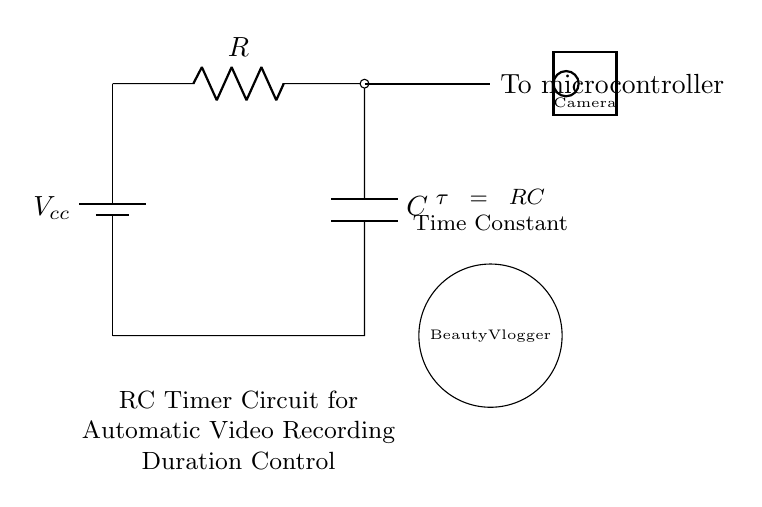What is the component labeled R? The component labeled R represents a resistor, which is used to limit current in the circuit.
Answer: Resistor What is the component labeled C? The component labeled C represents a capacitor, which stores electrical energy temporarily.
Answer: Capacitor What connects to the microcontroller? The output from the RC circuit, which is the point where the resistor and capacitor meet before going to the microcontroller, connects to it.
Answer: Resistor-Capacitor output What is the purpose of this circuit? This circuit is designed to control the duration of automatic video recording by utilizing the time constant from the resistor and capacitor.
Answer: Automatic video recording duration control What is the time constant of this circuit? The time constant (tau) of the circuit is calculated by the product of the resistor value and capacitor value, represented as tau equals RC.
Answer: RC How does the time constant impact the recording duration? The time constant determines how quickly the capacitor charges and discharges, directly affecting the time before the microcontroller receives a signal to stop recording based on the RC values.
Answer: It affects the delay before stopping recording What is the role of the battery in this circuit? The battery provides the necessary voltage supply for the circuit to function, enabling the operation of both the resistor and capacitor in the timing mechanism.
Answer: Voltage supply 